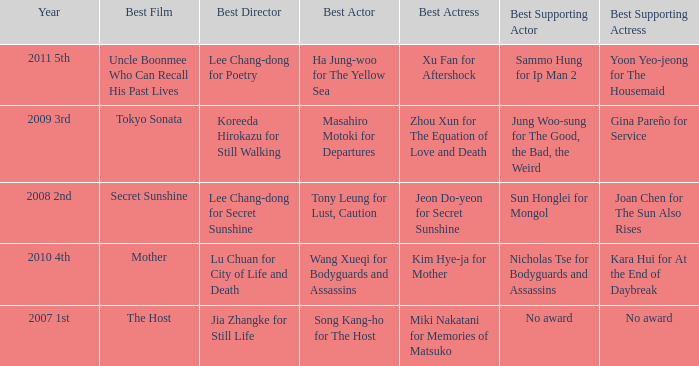Name the best actor for uncle boonmee who can recall his past lives Ha Jung-woo for The Yellow Sea. 